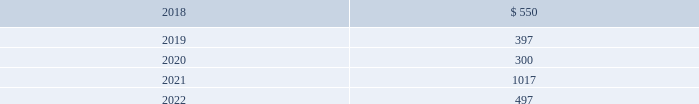In january 2016 , the company issued $ 800 million of debt securities consisting of a $ 400 million aggregate principal three year fixed rate note with a coupon rate of 2.00% ( 2.00 % ) and a $ 400 million aggregate principal seven year fixed rate note with a coupon rate of 3.25% ( 3.25 % ) .
The proceeds were used to repay a portion of the company 2019s outstanding commercial paper , repay the remaining term loan balance , and for general corporate purposes .
The company 2019s public notes and 144a notes may be redeemed by the company at its option at redemption prices that include accrued and unpaid interest and a make-whole premium .
Upon the occurrence of a change of control accompanied by a downgrade of the notes below investment grade rating , within a specified time period , the company would be required to offer to repurchase the public notes and 144a notes at a price equal to 101% ( 101 % ) of the aggregate principal amount thereof , plus any accrued and unpaid interest to the date of repurchase .
The public notes and 144a notes are senior unsecured and unsubordinated obligations of the company and rank equally with all other senior and unsubordinated indebtedness of the company .
The company entered into a registration rights agreement in connection with the issuance of the 144a notes .
Subject to certain limitations set forth in the registration rights agreement , the company has agreed to ( i ) file a registration statement ( the 201cexchange offer registration statement 201d ) with respect to registered offers to exchange the 144a notes for exchange notes ( the 201cexchange notes 201d ) , which will have terms identical in all material respects to the new 10-year notes and new 30-year notes , as applicable , except that the exchange notes will not contain transfer restrictions and will not provide for any increase in the interest rate thereon in certain circumstances and ( ii ) use commercially reasonable efforts to cause the exchange offer registration statement to be declared effective within 270 days after the date of issuance of the 144a notes .
Until such time as the exchange offer registration statement is declared effective , the 144a notes may only be sold in accordance with rule 144a or regulation s of the securities act of 1933 , as amended .
Private notes the company 2019s private notes may be redeemed by the company at its option at redemption prices that include accrued and unpaid interest and a make-whole premium .
Upon the occurrence of specified changes of control involving the company , the company would be required to offer to repurchase the private notes at a price equal to 100% ( 100 % ) of the aggregate principal amount thereof , plus any accrued and unpaid interest to the date of repurchase .
Additionally , the company would be required to make a similar offer to repurchase the private notes upon the occurrence of specified merger events or asset sales involving the company , when accompanied by a downgrade of the private notes below investment grade rating , within a specified time period .
The private notes are unsecured senior obligations of the company and rank equal in right of payment with all other senior indebtedness of the company .
The private notes shall be unconditionally guaranteed by subsidiaries of the company in certain circumstances , as described in the note purchase agreements as amended .
Other debt during 2015 , the company acquired the beneficial interest in the trust owning the leased naperville facility resulting in debt assumption of $ 100.2 million and the addition of $ 135.2 million in property , plant and equipment .
Certain administrative , divisional , and research and development personnel are based at the naperville facility .
Cash paid as a result of the transaction was $ 19.8 million .
The assumption of debt and the majority of the property , plant and equipment addition represented non-cash financing and investing activities , respectively .
The remaining balance on the assumed debt was settled in december 2017 and was reflected in the "other" line of the table above at december 31 , 2016 .
Covenants and future maturities the company is in compliance with all covenants under the company 2019s outstanding indebtedness at december 31 , 2017 .
As of december 31 , 2017 , the aggregate annual maturities of long-term debt for the next five years were : ( millions ) .

What is the yearly interest expense related to the 3.25% ( 3.25 % ) note issued in january 2016 , in millions? 
Computations: (400 * 3.25%)
Answer: 13.0. 